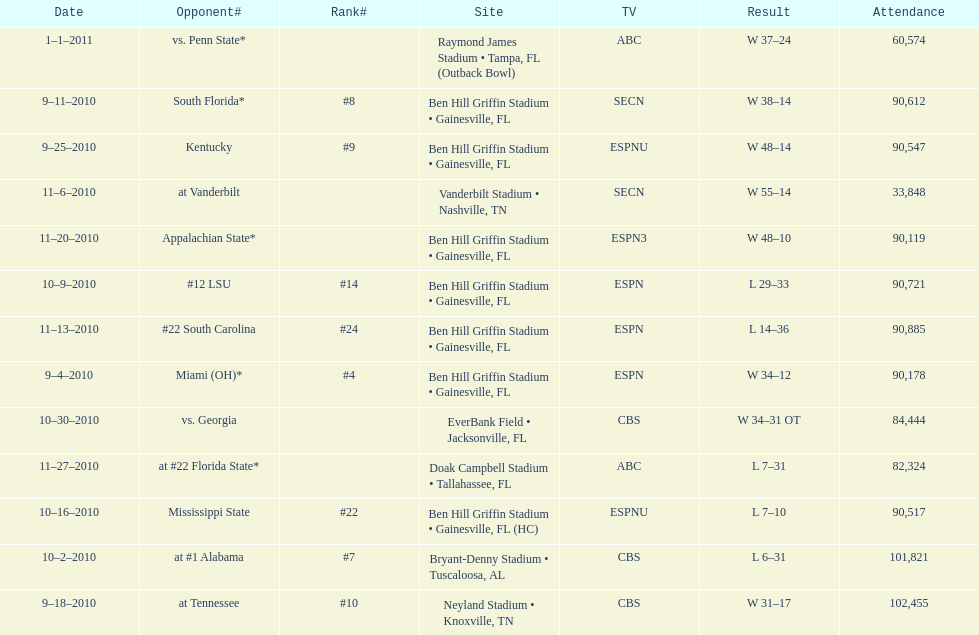What was the most the university of florida won by? 41 points. 